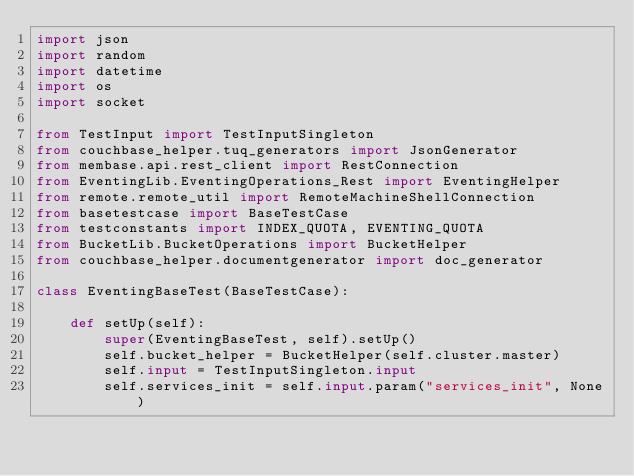<code> <loc_0><loc_0><loc_500><loc_500><_Python_>import json
import random
import datetime
import os
import socket

from TestInput import TestInputSingleton
from couchbase_helper.tuq_generators import JsonGenerator
from membase.api.rest_client import RestConnection
from EventingLib.EventingOperations_Rest import EventingHelper
from remote.remote_util import RemoteMachineShellConnection
from basetestcase import BaseTestCase
from testconstants import INDEX_QUOTA, EVENTING_QUOTA
from BucketLib.BucketOperations import BucketHelper
from couchbase_helper.documentgenerator import doc_generator

class EventingBaseTest(BaseTestCase):

    def setUp(self):
        super(EventingBaseTest, self).setUp()
        self.bucket_helper = BucketHelper(self.cluster.master)
        self.input = TestInputSingleton.input
        self.services_init = self.input.param("services_init", None)</code> 